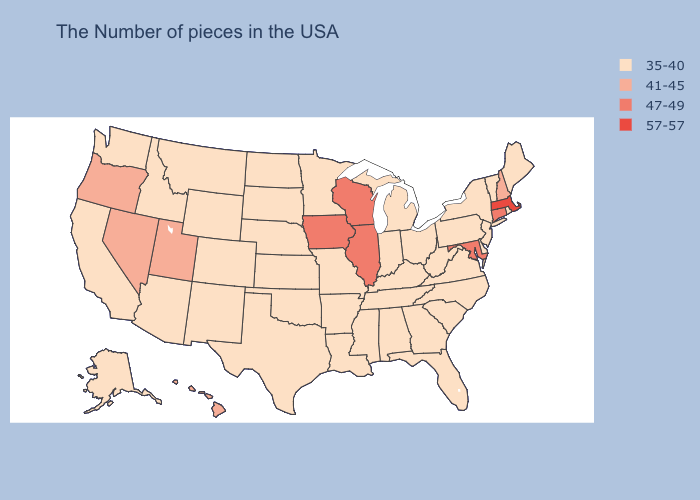Name the states that have a value in the range 41-45?
Keep it brief. New Hampshire, Utah, Nevada, Oregon, Hawaii. Among the states that border Rhode Island , does Connecticut have the highest value?
Concise answer only. No. Among the states that border Virginia , which have the highest value?
Answer briefly. Maryland. What is the value of Illinois?
Short answer required. 47-49. Does California have the lowest value in the West?
Give a very brief answer. Yes. What is the value of Alaska?
Keep it brief. 35-40. Does California have the highest value in the USA?
Quick response, please. No. What is the lowest value in states that border Montana?
Quick response, please. 35-40. Which states have the highest value in the USA?
Short answer required. Massachusetts. Among the states that border Rhode Island , does Connecticut have the lowest value?
Keep it brief. Yes. Which states have the lowest value in the West?
Answer briefly. Wyoming, Colorado, New Mexico, Montana, Arizona, Idaho, California, Washington, Alaska. Name the states that have a value in the range 47-49?
Short answer required. Connecticut, Maryland, Wisconsin, Illinois, Iowa. Is the legend a continuous bar?
Keep it brief. No. Name the states that have a value in the range 47-49?
Be succinct. Connecticut, Maryland, Wisconsin, Illinois, Iowa. What is the value of West Virginia?
Write a very short answer. 35-40. 